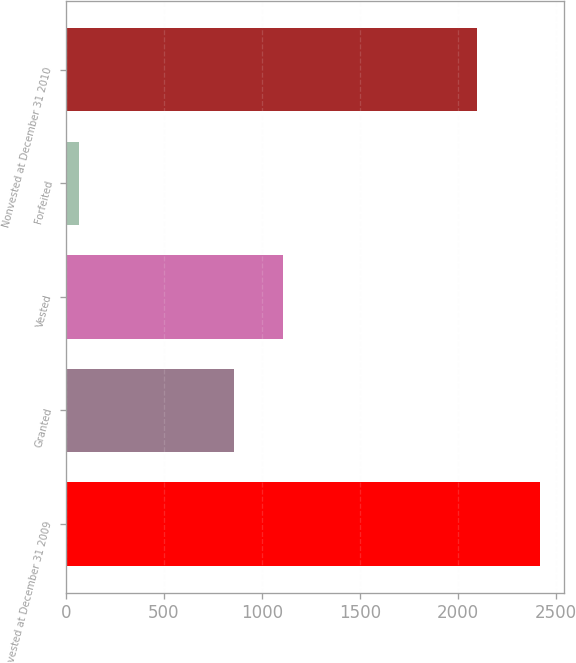Convert chart to OTSL. <chart><loc_0><loc_0><loc_500><loc_500><bar_chart><fcel>Nonvested at December 31 2009<fcel>Granted<fcel>Vested<fcel>Forfeited<fcel>Nonvested at December 31 2010<nl><fcel>2420<fcel>856<fcel>1108<fcel>69<fcel>2099<nl></chart> 